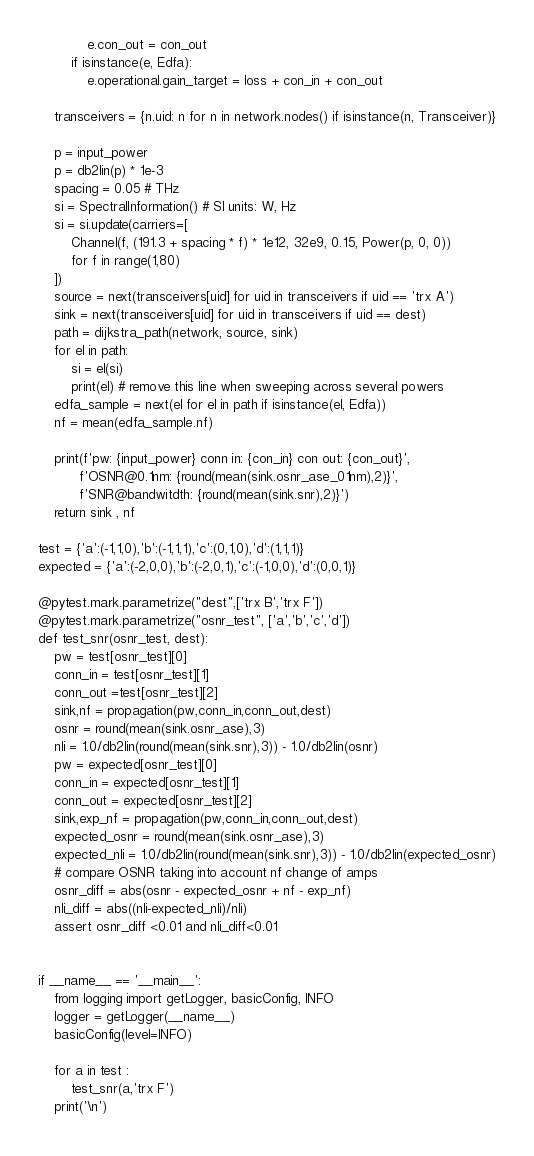<code> <loc_0><loc_0><loc_500><loc_500><_Python_>            e.con_out = con_out
        if isinstance(e, Edfa):
            e.operational.gain_target = loss + con_in + con_out

    transceivers = {n.uid: n for n in network.nodes() if isinstance(n, Transceiver)}

    p = input_power
    p = db2lin(p) * 1e-3
    spacing = 0.05 # THz
    si = SpectralInformation() # SI units: W, Hz
    si = si.update(carriers=[
        Channel(f, (191.3 + spacing * f) * 1e12, 32e9, 0.15, Power(p, 0, 0))
        for f in range(1,80)
    ])
    source = next(transceivers[uid] for uid in transceivers if uid == 'trx A')
    sink = next(transceivers[uid] for uid in transceivers if uid == dest)
    path = dijkstra_path(network, source, sink)
    for el in path:
        si = el(si)
        print(el) # remove this line when sweeping across several powers
    edfa_sample = next(el for el in path if isinstance(el, Edfa))
    nf = mean(edfa_sample.nf)

    print(f'pw: {input_power} conn in: {con_in} con out: {con_out}',
          f'OSNR@0.1nm: {round(mean(sink.osnr_ase_01nm),2)}',
          f'SNR@bandwitdth: {round(mean(sink.snr),2)}')
    return sink , nf

test = {'a':(-1,1,0),'b':(-1,1,1),'c':(0,1,0),'d':(1,1,1)}
expected = {'a':(-2,0,0),'b':(-2,0,1),'c':(-1,0,0),'d':(0,0,1)}

@pytest.mark.parametrize("dest",['trx B','trx F'])
@pytest.mark.parametrize("osnr_test", ['a','b','c','d'])
def test_snr(osnr_test, dest):
    pw = test[osnr_test][0]
    conn_in = test[osnr_test][1]
    conn_out =test[osnr_test][2]
    sink,nf = propagation(pw,conn_in,conn_out,dest)
    osnr = round(mean(sink.osnr_ase),3)
    nli = 1.0/db2lin(round(mean(sink.snr),3)) - 1.0/db2lin(osnr)
    pw = expected[osnr_test][0]
    conn_in = expected[osnr_test][1]
    conn_out = expected[osnr_test][2]
    sink,exp_nf = propagation(pw,conn_in,conn_out,dest)
    expected_osnr = round(mean(sink.osnr_ase),3)
    expected_nli = 1.0/db2lin(round(mean(sink.snr),3)) - 1.0/db2lin(expected_osnr)
    # compare OSNR taking into account nf change of amps
    osnr_diff = abs(osnr - expected_osnr + nf - exp_nf)
    nli_diff = abs((nli-expected_nli)/nli)
    assert osnr_diff <0.01 and nli_diff<0.01


if __name__ == '__main__':
    from logging import getLogger, basicConfig, INFO
    logger = getLogger(__name__)
    basicConfig(level=INFO)

    for a in test :
        test_snr(a,'trx F')
    print('\n')
</code> 